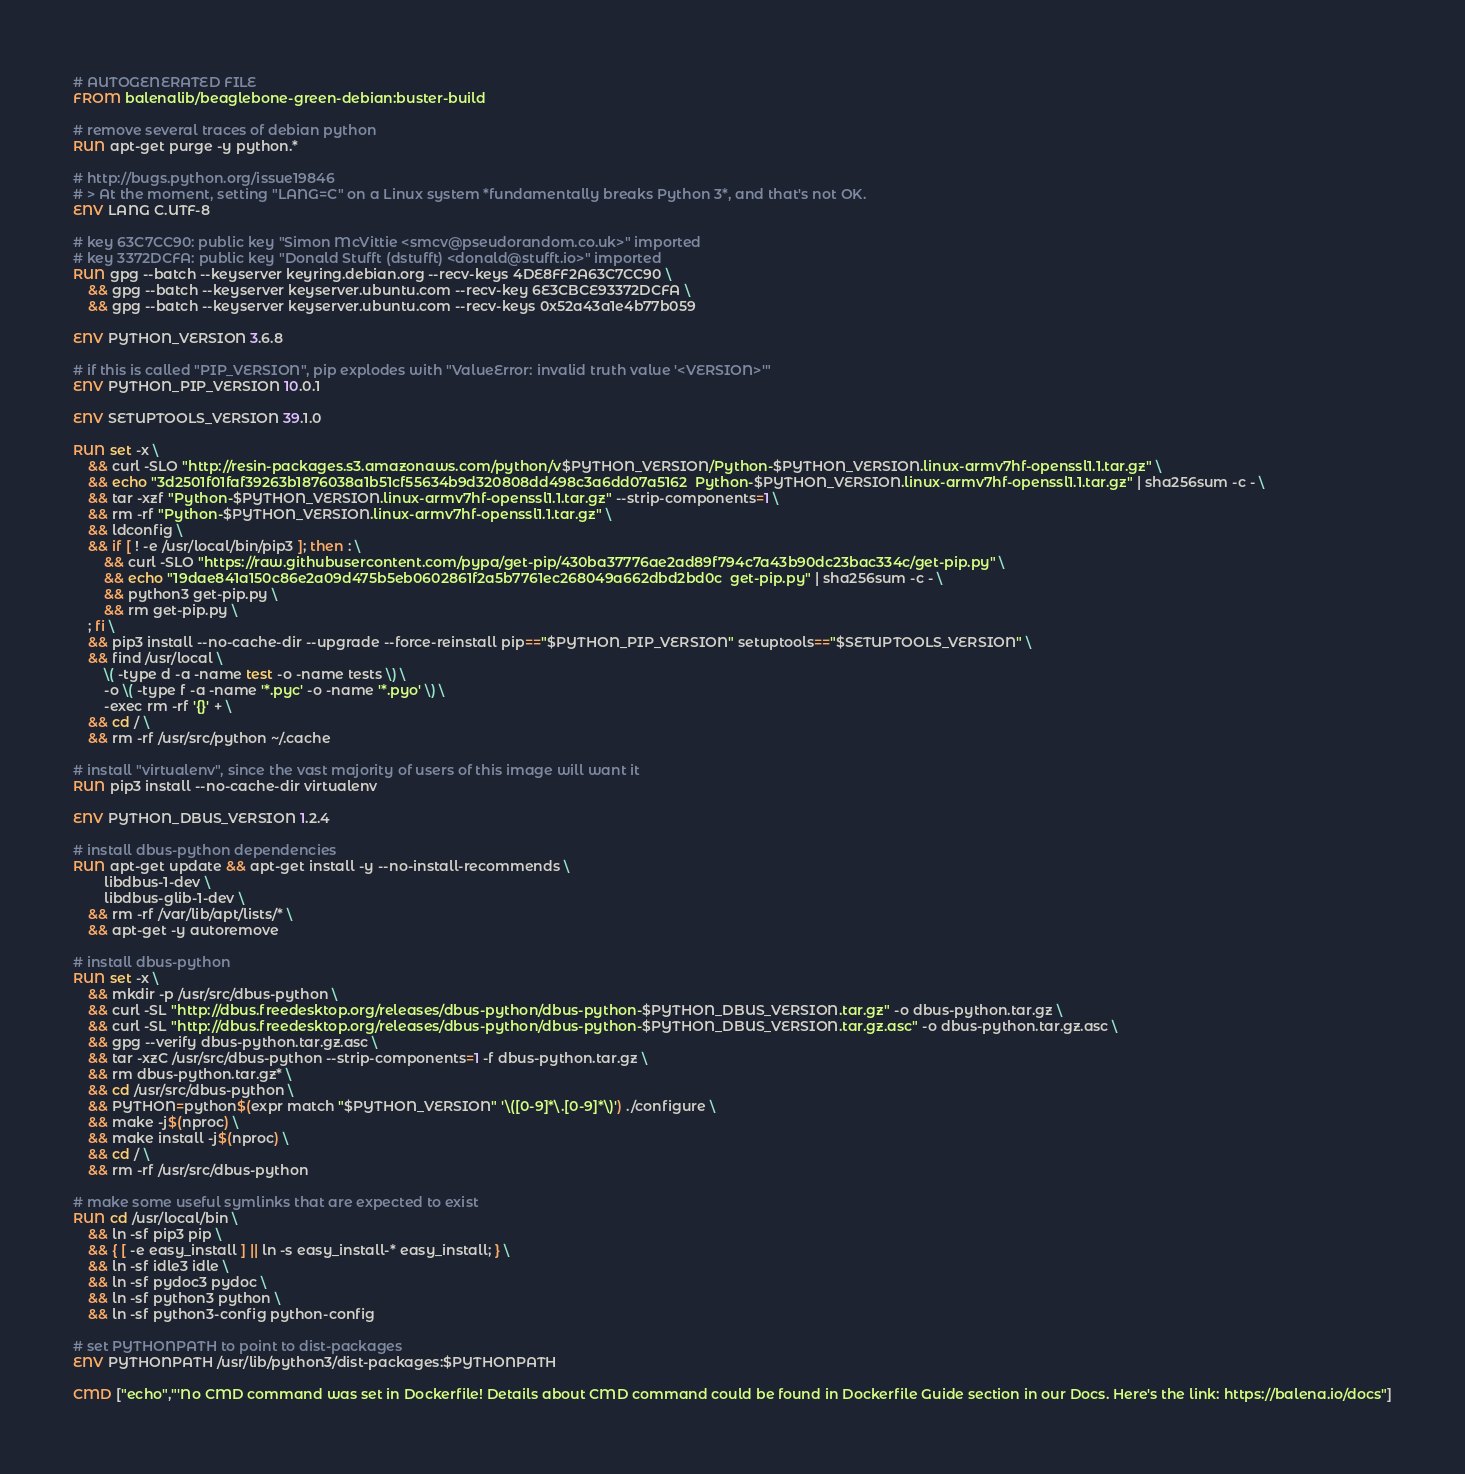Convert code to text. <code><loc_0><loc_0><loc_500><loc_500><_Dockerfile_># AUTOGENERATED FILE
FROM balenalib/beaglebone-green-debian:buster-build

# remove several traces of debian python
RUN apt-get purge -y python.*

# http://bugs.python.org/issue19846
# > At the moment, setting "LANG=C" on a Linux system *fundamentally breaks Python 3*, and that's not OK.
ENV LANG C.UTF-8

# key 63C7CC90: public key "Simon McVittie <smcv@pseudorandom.co.uk>" imported
# key 3372DCFA: public key "Donald Stufft (dstufft) <donald@stufft.io>" imported
RUN gpg --batch --keyserver keyring.debian.org --recv-keys 4DE8FF2A63C7CC90 \
	&& gpg --batch --keyserver keyserver.ubuntu.com --recv-key 6E3CBCE93372DCFA \
	&& gpg --batch --keyserver keyserver.ubuntu.com --recv-keys 0x52a43a1e4b77b059

ENV PYTHON_VERSION 3.6.8

# if this is called "PIP_VERSION", pip explodes with "ValueError: invalid truth value '<VERSION>'"
ENV PYTHON_PIP_VERSION 10.0.1

ENV SETUPTOOLS_VERSION 39.1.0

RUN set -x \
	&& curl -SLO "http://resin-packages.s3.amazonaws.com/python/v$PYTHON_VERSION/Python-$PYTHON_VERSION.linux-armv7hf-openssl1.1.tar.gz" \
	&& echo "3d2501f01faf39263b1876038a1b51cf55634b9d320808dd498c3a6dd07a5162  Python-$PYTHON_VERSION.linux-armv7hf-openssl1.1.tar.gz" | sha256sum -c - \
	&& tar -xzf "Python-$PYTHON_VERSION.linux-armv7hf-openssl1.1.tar.gz" --strip-components=1 \
	&& rm -rf "Python-$PYTHON_VERSION.linux-armv7hf-openssl1.1.tar.gz" \
	&& ldconfig \
	&& if [ ! -e /usr/local/bin/pip3 ]; then : \
		&& curl -SLO "https://raw.githubusercontent.com/pypa/get-pip/430ba37776ae2ad89f794c7a43b90dc23bac334c/get-pip.py" \
		&& echo "19dae841a150c86e2a09d475b5eb0602861f2a5b7761ec268049a662dbd2bd0c  get-pip.py" | sha256sum -c - \
		&& python3 get-pip.py \
		&& rm get-pip.py \
	; fi \
	&& pip3 install --no-cache-dir --upgrade --force-reinstall pip=="$PYTHON_PIP_VERSION" setuptools=="$SETUPTOOLS_VERSION" \
	&& find /usr/local \
		\( -type d -a -name test -o -name tests \) \
		-o \( -type f -a -name '*.pyc' -o -name '*.pyo' \) \
		-exec rm -rf '{}' + \
	&& cd / \
	&& rm -rf /usr/src/python ~/.cache

# install "virtualenv", since the vast majority of users of this image will want it
RUN pip3 install --no-cache-dir virtualenv

ENV PYTHON_DBUS_VERSION 1.2.4

# install dbus-python dependencies 
RUN apt-get update && apt-get install -y --no-install-recommends \
		libdbus-1-dev \
		libdbus-glib-1-dev \
	&& rm -rf /var/lib/apt/lists/* \
	&& apt-get -y autoremove

# install dbus-python
RUN set -x \
	&& mkdir -p /usr/src/dbus-python \
	&& curl -SL "http://dbus.freedesktop.org/releases/dbus-python/dbus-python-$PYTHON_DBUS_VERSION.tar.gz" -o dbus-python.tar.gz \
	&& curl -SL "http://dbus.freedesktop.org/releases/dbus-python/dbus-python-$PYTHON_DBUS_VERSION.tar.gz.asc" -o dbus-python.tar.gz.asc \
	&& gpg --verify dbus-python.tar.gz.asc \
	&& tar -xzC /usr/src/dbus-python --strip-components=1 -f dbus-python.tar.gz \
	&& rm dbus-python.tar.gz* \
	&& cd /usr/src/dbus-python \
	&& PYTHON=python$(expr match "$PYTHON_VERSION" '\([0-9]*\.[0-9]*\)') ./configure \
	&& make -j$(nproc) \
	&& make install -j$(nproc) \
	&& cd / \
	&& rm -rf /usr/src/dbus-python

# make some useful symlinks that are expected to exist
RUN cd /usr/local/bin \
	&& ln -sf pip3 pip \
	&& { [ -e easy_install ] || ln -s easy_install-* easy_install; } \
	&& ln -sf idle3 idle \
	&& ln -sf pydoc3 pydoc \
	&& ln -sf python3 python \
	&& ln -sf python3-config python-config

# set PYTHONPATH to point to dist-packages
ENV PYTHONPATH /usr/lib/python3/dist-packages:$PYTHONPATH

CMD ["echo","'No CMD command was set in Dockerfile! Details about CMD command could be found in Dockerfile Guide section in our Docs. Here's the link: https://balena.io/docs"]</code> 